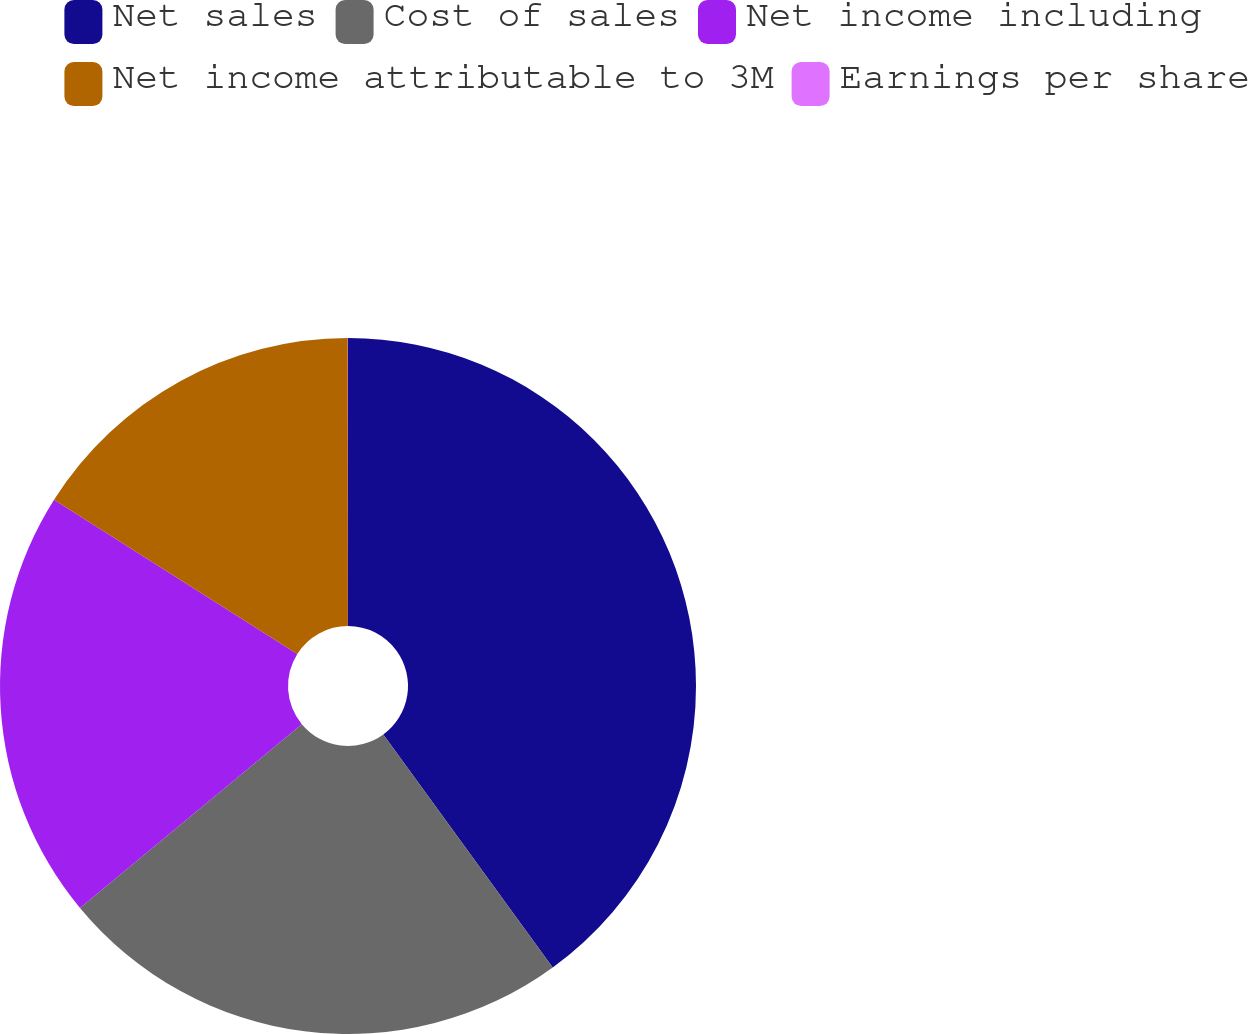Convert chart. <chart><loc_0><loc_0><loc_500><loc_500><pie_chart><fcel>Net sales<fcel>Cost of sales<fcel>Net income including<fcel>Net income attributable to 3M<fcel>Earnings per share<nl><fcel>39.99%<fcel>24.0%<fcel>20.0%<fcel>16.0%<fcel>0.01%<nl></chart> 